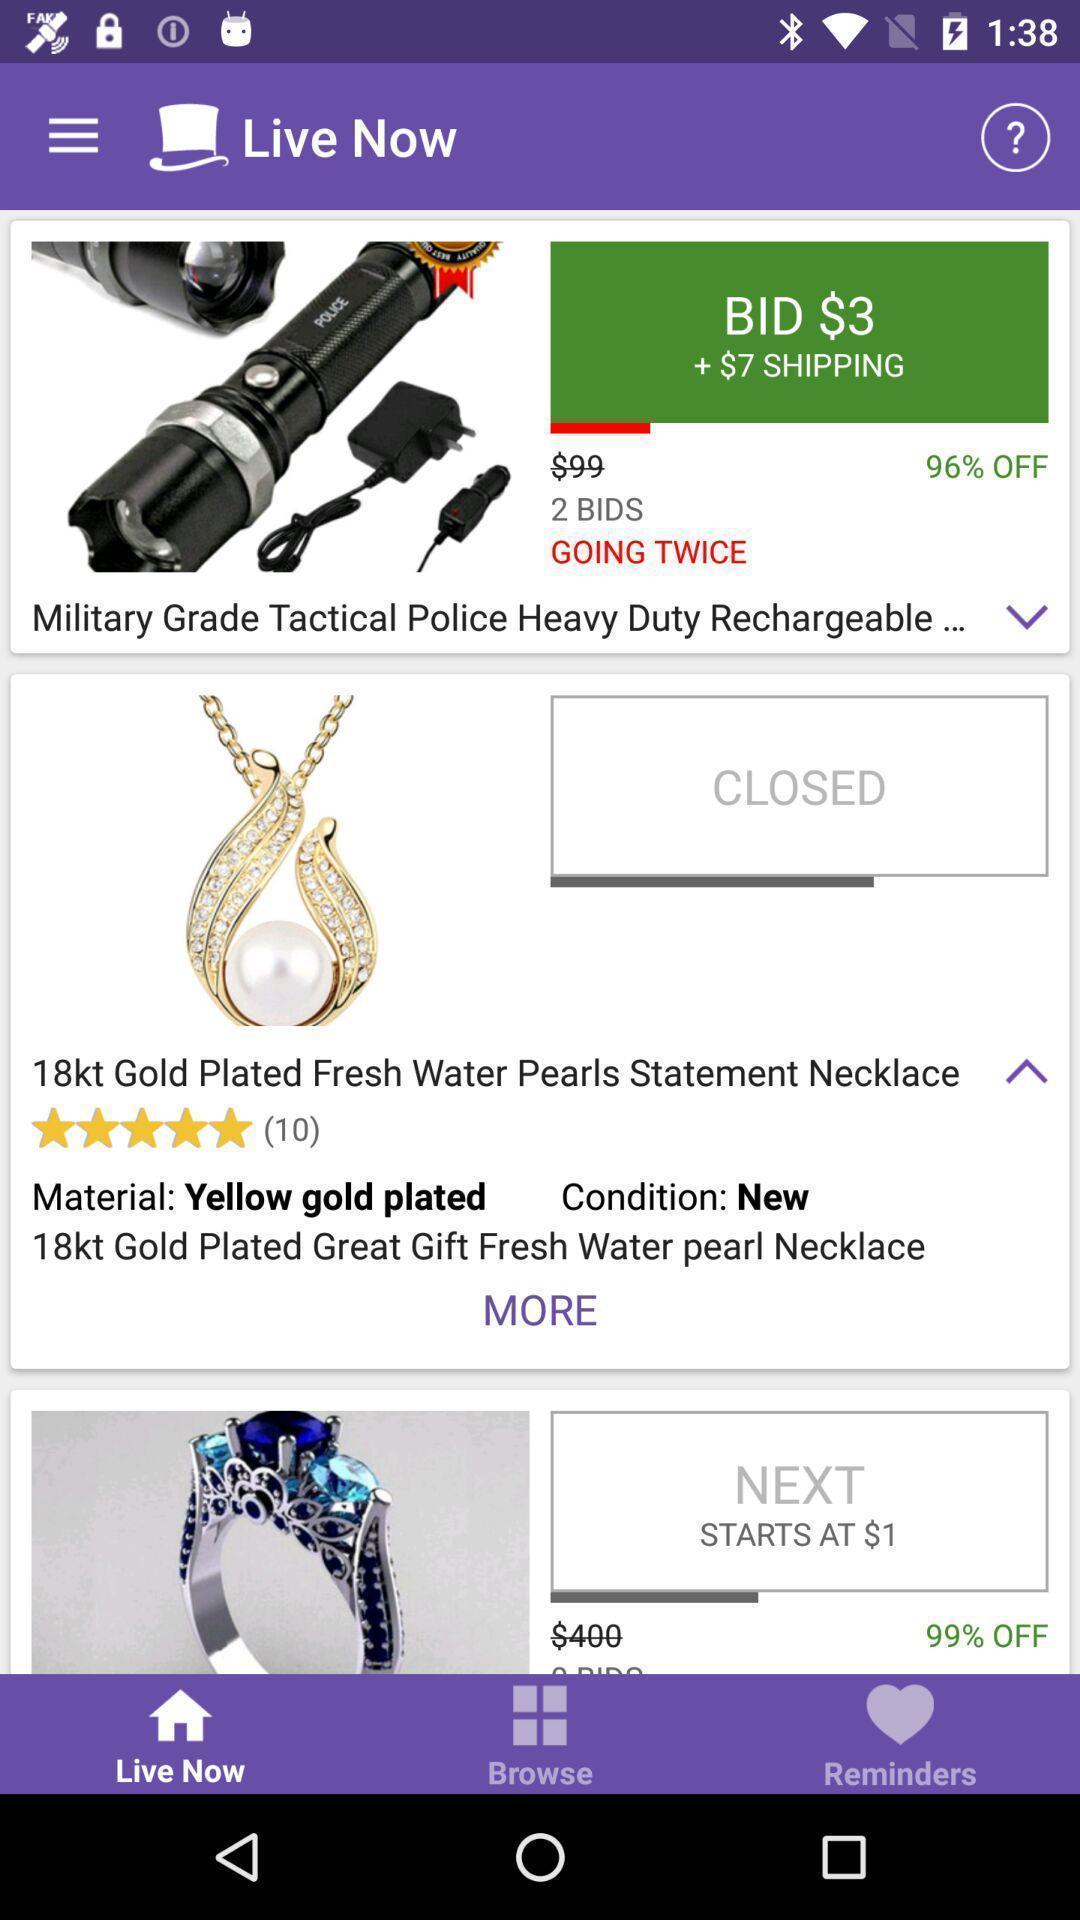What can you discern from this picture? Page showing different options in a shopping app. 